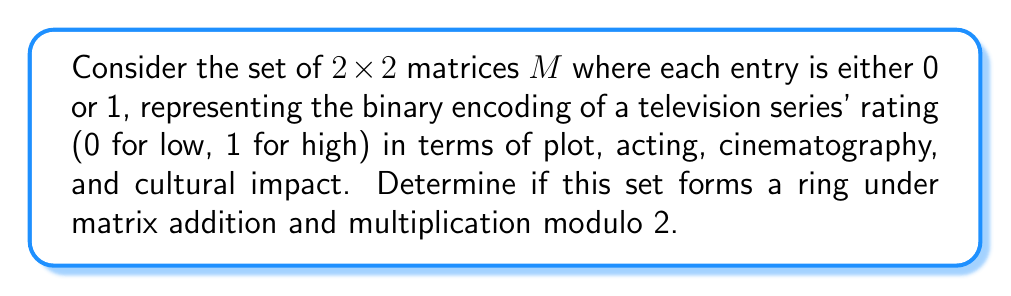Provide a solution to this math problem. To determine if the set $M$ forms a ring, we need to check if it satisfies all the ring axioms under matrix addition and multiplication modulo 2.

1. Closure under addition and multiplication:
   For any $A, B \in M$, $A + B$ and $AB$ (mod 2) will always result in matrices with entries 0 or 1.

2. Associativity of addition and multiplication:
   Matrix addition and multiplication are always associative.

3. Commutativity of addition:
   Matrix addition is commutative: $A + B = B + A$ for all $A, B \in M$.

4. Additive identity:
   The zero matrix $\begin{pmatrix} 0 & 0 \\ 0 & 0 \end{pmatrix}$ is in $M$ and serves as the additive identity.

5. Additive inverse:
   Since we're working modulo 2, each matrix is its own additive inverse.

6. Distributive property:
   Matrix multiplication distributes over addition: $A(B+C) = AB + AC$ and $(B+C)A = BA + CA$ for all $A, B, C \in M$.

7. Multiplicative identity:
   The identity matrix $\begin{pmatrix} 1 & 0 \\ 0 & 1 \end{pmatrix}$ is in $M$ and serves as the multiplicative identity.

All ring axioms are satisfied, so $M$ forms a ring under matrix addition and multiplication modulo 2.
Answer: Yes, the set $M$ forms a ring under matrix addition and multiplication modulo 2. 